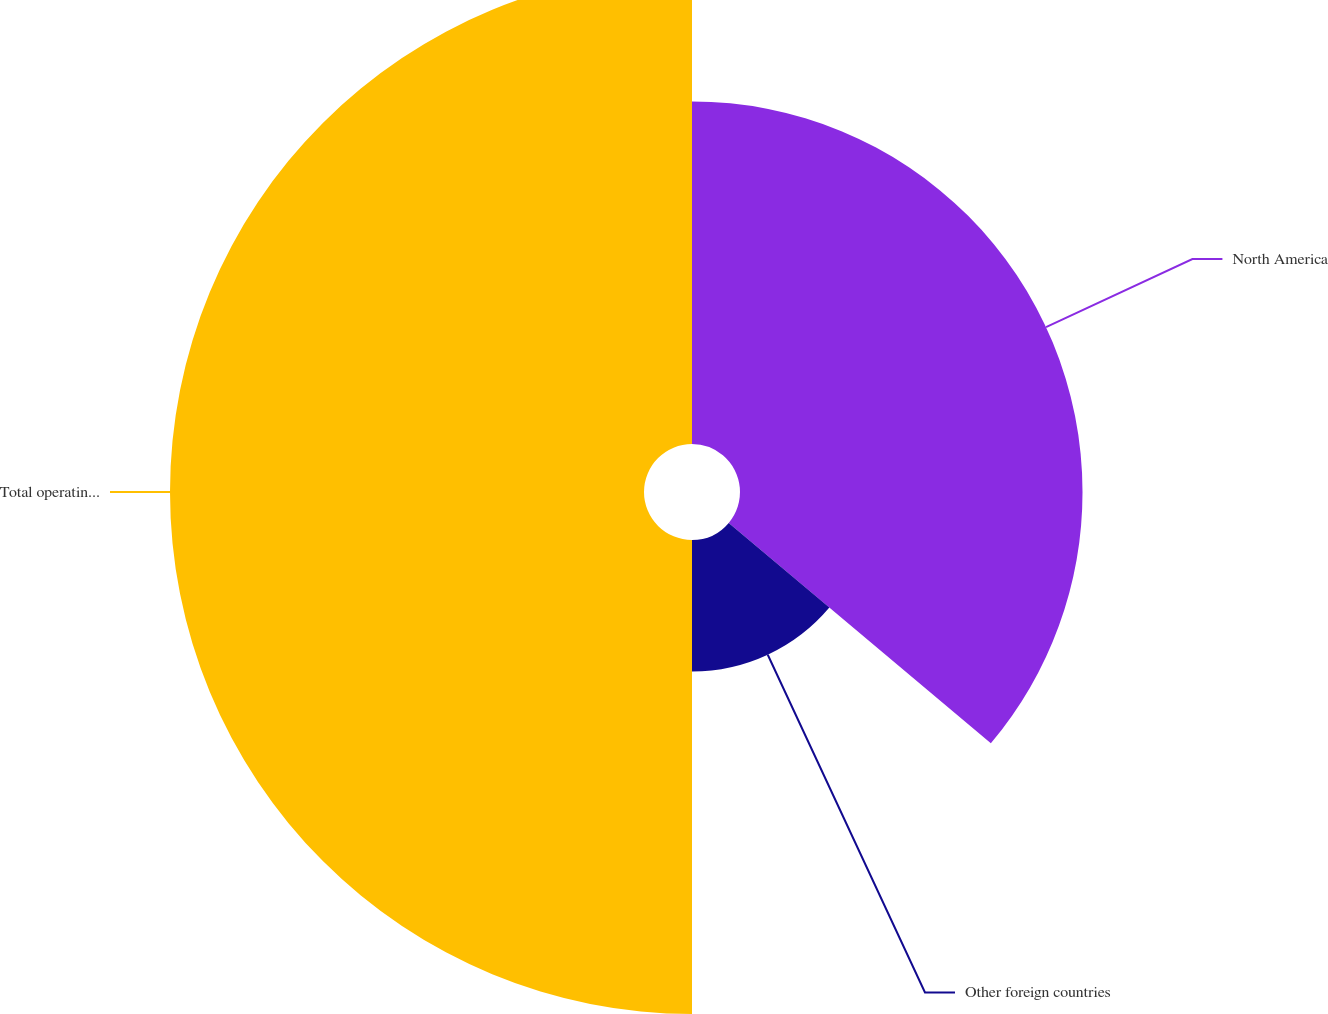<chart> <loc_0><loc_0><loc_500><loc_500><pie_chart><fcel>North America<fcel>Other foreign countries<fcel>Total operating income<nl><fcel>36.13%<fcel>13.87%<fcel>50.0%<nl></chart> 